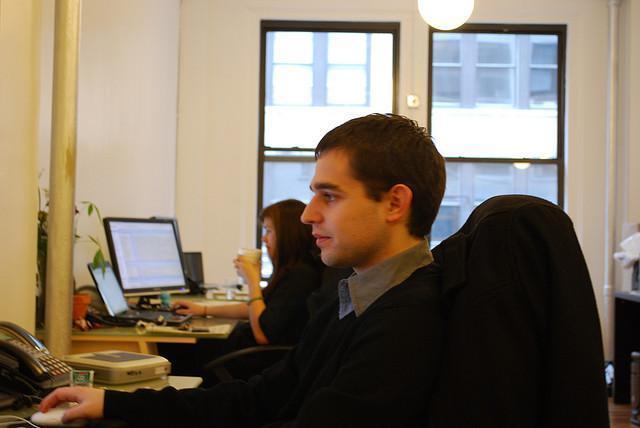What is he doing?
Choose the right answer from the provided options to respond to the question.
Options: Watching tv, making dinner, using computer, showing off. Using computer. 